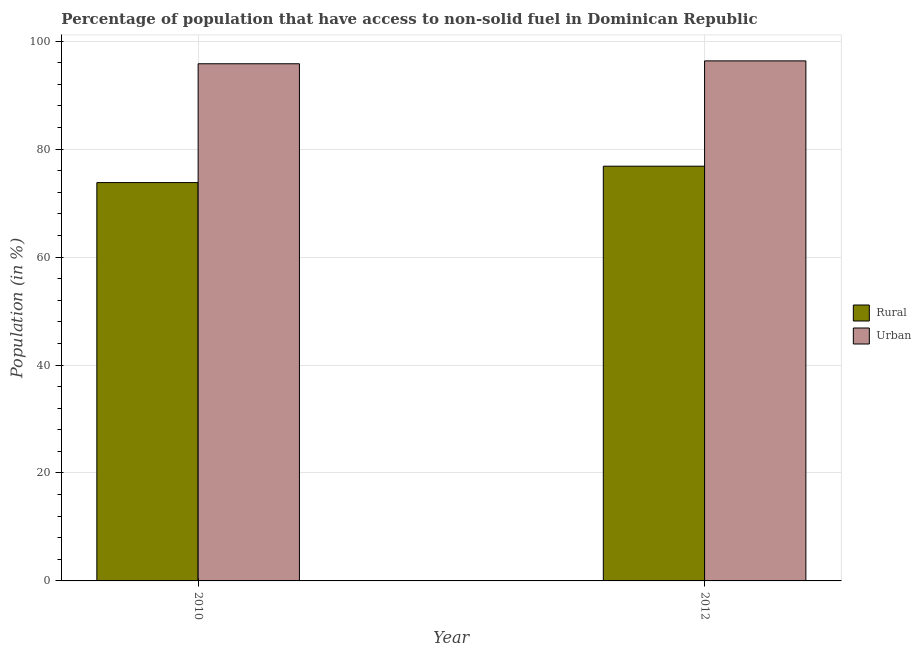How many different coloured bars are there?
Give a very brief answer. 2. How many groups of bars are there?
Provide a short and direct response. 2. How many bars are there on the 1st tick from the left?
Ensure brevity in your answer.  2. What is the rural population in 2012?
Make the answer very short. 76.84. Across all years, what is the maximum urban population?
Your answer should be very brief. 96.35. Across all years, what is the minimum urban population?
Your response must be concise. 95.82. In which year was the urban population maximum?
Give a very brief answer. 2012. In which year was the rural population minimum?
Offer a terse response. 2010. What is the total rural population in the graph?
Your answer should be compact. 150.65. What is the difference between the urban population in 2010 and that in 2012?
Your answer should be very brief. -0.53. What is the difference between the urban population in 2012 and the rural population in 2010?
Make the answer very short. 0.53. What is the average urban population per year?
Your answer should be compact. 96.09. In the year 2012, what is the difference between the urban population and rural population?
Ensure brevity in your answer.  0. What is the ratio of the urban population in 2010 to that in 2012?
Provide a succinct answer. 0.99. Is the rural population in 2010 less than that in 2012?
Ensure brevity in your answer.  Yes. What does the 1st bar from the left in 2012 represents?
Your answer should be compact. Rural. What does the 2nd bar from the right in 2012 represents?
Your answer should be very brief. Rural. Are all the bars in the graph horizontal?
Provide a short and direct response. No. How many years are there in the graph?
Offer a very short reply. 2. What is the difference between two consecutive major ticks on the Y-axis?
Ensure brevity in your answer.  20. Are the values on the major ticks of Y-axis written in scientific E-notation?
Give a very brief answer. No. Does the graph contain any zero values?
Keep it short and to the point. No. Does the graph contain grids?
Keep it short and to the point. Yes. How many legend labels are there?
Keep it short and to the point. 2. How are the legend labels stacked?
Keep it short and to the point. Vertical. What is the title of the graph?
Provide a short and direct response. Percentage of population that have access to non-solid fuel in Dominican Republic. What is the label or title of the X-axis?
Make the answer very short. Year. What is the label or title of the Y-axis?
Ensure brevity in your answer.  Population (in %). What is the Population (in %) in Rural in 2010?
Provide a short and direct response. 73.8. What is the Population (in %) in Urban in 2010?
Give a very brief answer. 95.82. What is the Population (in %) in Rural in 2012?
Offer a very short reply. 76.84. What is the Population (in %) in Urban in 2012?
Make the answer very short. 96.35. Across all years, what is the maximum Population (in %) in Rural?
Your answer should be compact. 76.84. Across all years, what is the maximum Population (in %) in Urban?
Your answer should be very brief. 96.35. Across all years, what is the minimum Population (in %) in Rural?
Your answer should be compact. 73.8. Across all years, what is the minimum Population (in %) in Urban?
Ensure brevity in your answer.  95.82. What is the total Population (in %) in Rural in the graph?
Provide a short and direct response. 150.65. What is the total Population (in %) in Urban in the graph?
Your answer should be very brief. 192.18. What is the difference between the Population (in %) in Rural in 2010 and that in 2012?
Your response must be concise. -3.04. What is the difference between the Population (in %) of Urban in 2010 and that in 2012?
Your answer should be very brief. -0.53. What is the difference between the Population (in %) of Rural in 2010 and the Population (in %) of Urban in 2012?
Ensure brevity in your answer.  -22.55. What is the average Population (in %) in Rural per year?
Keep it short and to the point. 75.32. What is the average Population (in %) of Urban per year?
Offer a terse response. 96.09. In the year 2010, what is the difference between the Population (in %) of Rural and Population (in %) of Urban?
Give a very brief answer. -22.02. In the year 2012, what is the difference between the Population (in %) in Rural and Population (in %) in Urban?
Offer a very short reply. -19.51. What is the ratio of the Population (in %) in Rural in 2010 to that in 2012?
Your response must be concise. 0.96. What is the ratio of the Population (in %) of Urban in 2010 to that in 2012?
Provide a succinct answer. 0.99. What is the difference between the highest and the second highest Population (in %) in Rural?
Ensure brevity in your answer.  3.04. What is the difference between the highest and the second highest Population (in %) in Urban?
Provide a succinct answer. 0.53. What is the difference between the highest and the lowest Population (in %) in Rural?
Keep it short and to the point. 3.04. What is the difference between the highest and the lowest Population (in %) of Urban?
Your response must be concise. 0.53. 